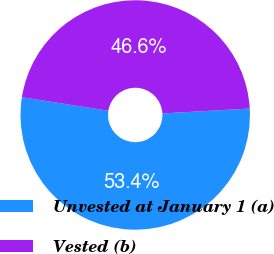<chart> <loc_0><loc_0><loc_500><loc_500><pie_chart><fcel>Unvested at January 1 (a)<fcel>Vested (b)<nl><fcel>53.36%<fcel>46.64%<nl></chart> 